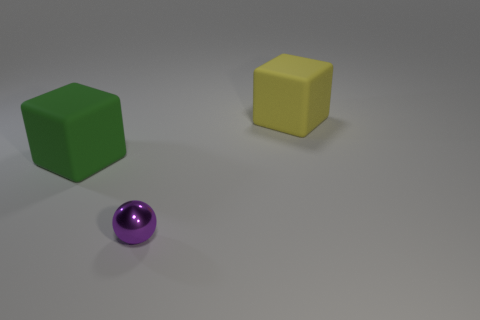Add 3 gray metal things. How many objects exist? 6 Subtract all spheres. How many objects are left? 2 Add 1 large green matte cubes. How many large green matte cubes are left? 2 Add 1 yellow rubber things. How many yellow rubber things exist? 2 Subtract 0 cyan spheres. How many objects are left? 3 Subtract all big matte balls. Subtract all small purple metal objects. How many objects are left? 2 